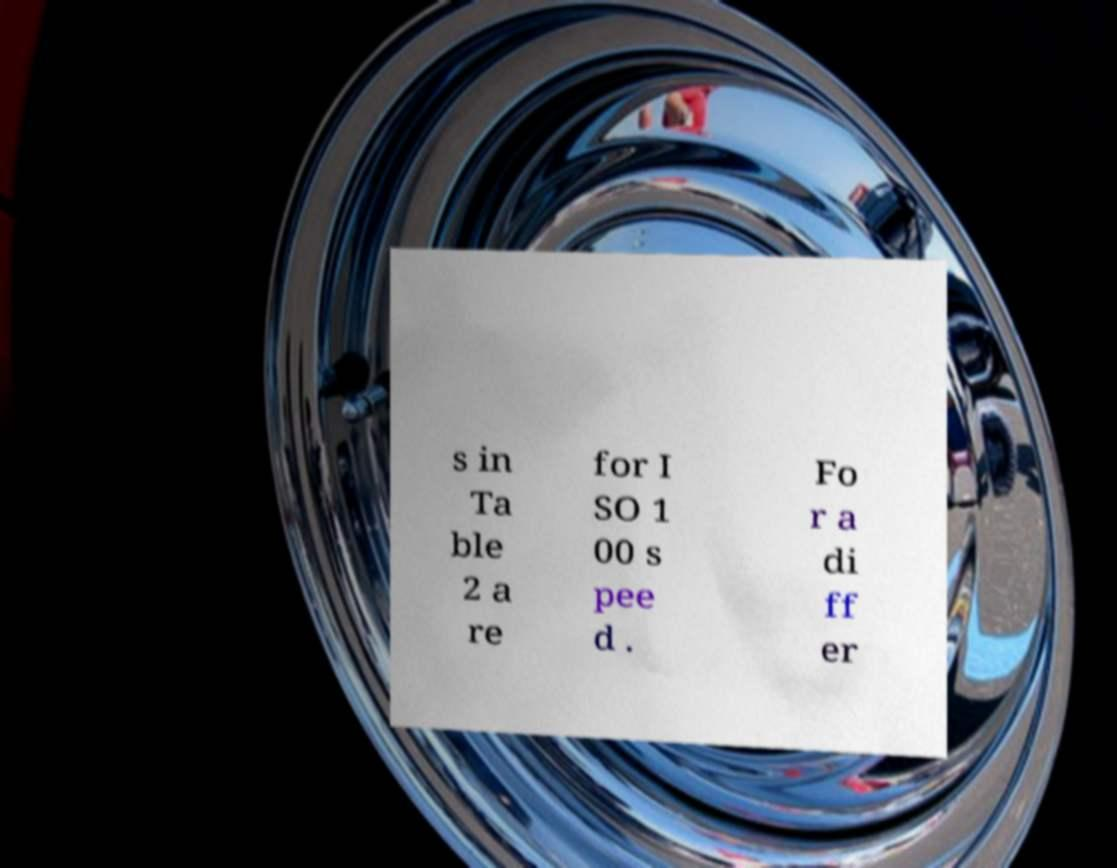What messages or text are displayed in this image? I need them in a readable, typed format. s in Ta ble 2 a re for I SO 1 00 s pee d . Fo r a di ff er 